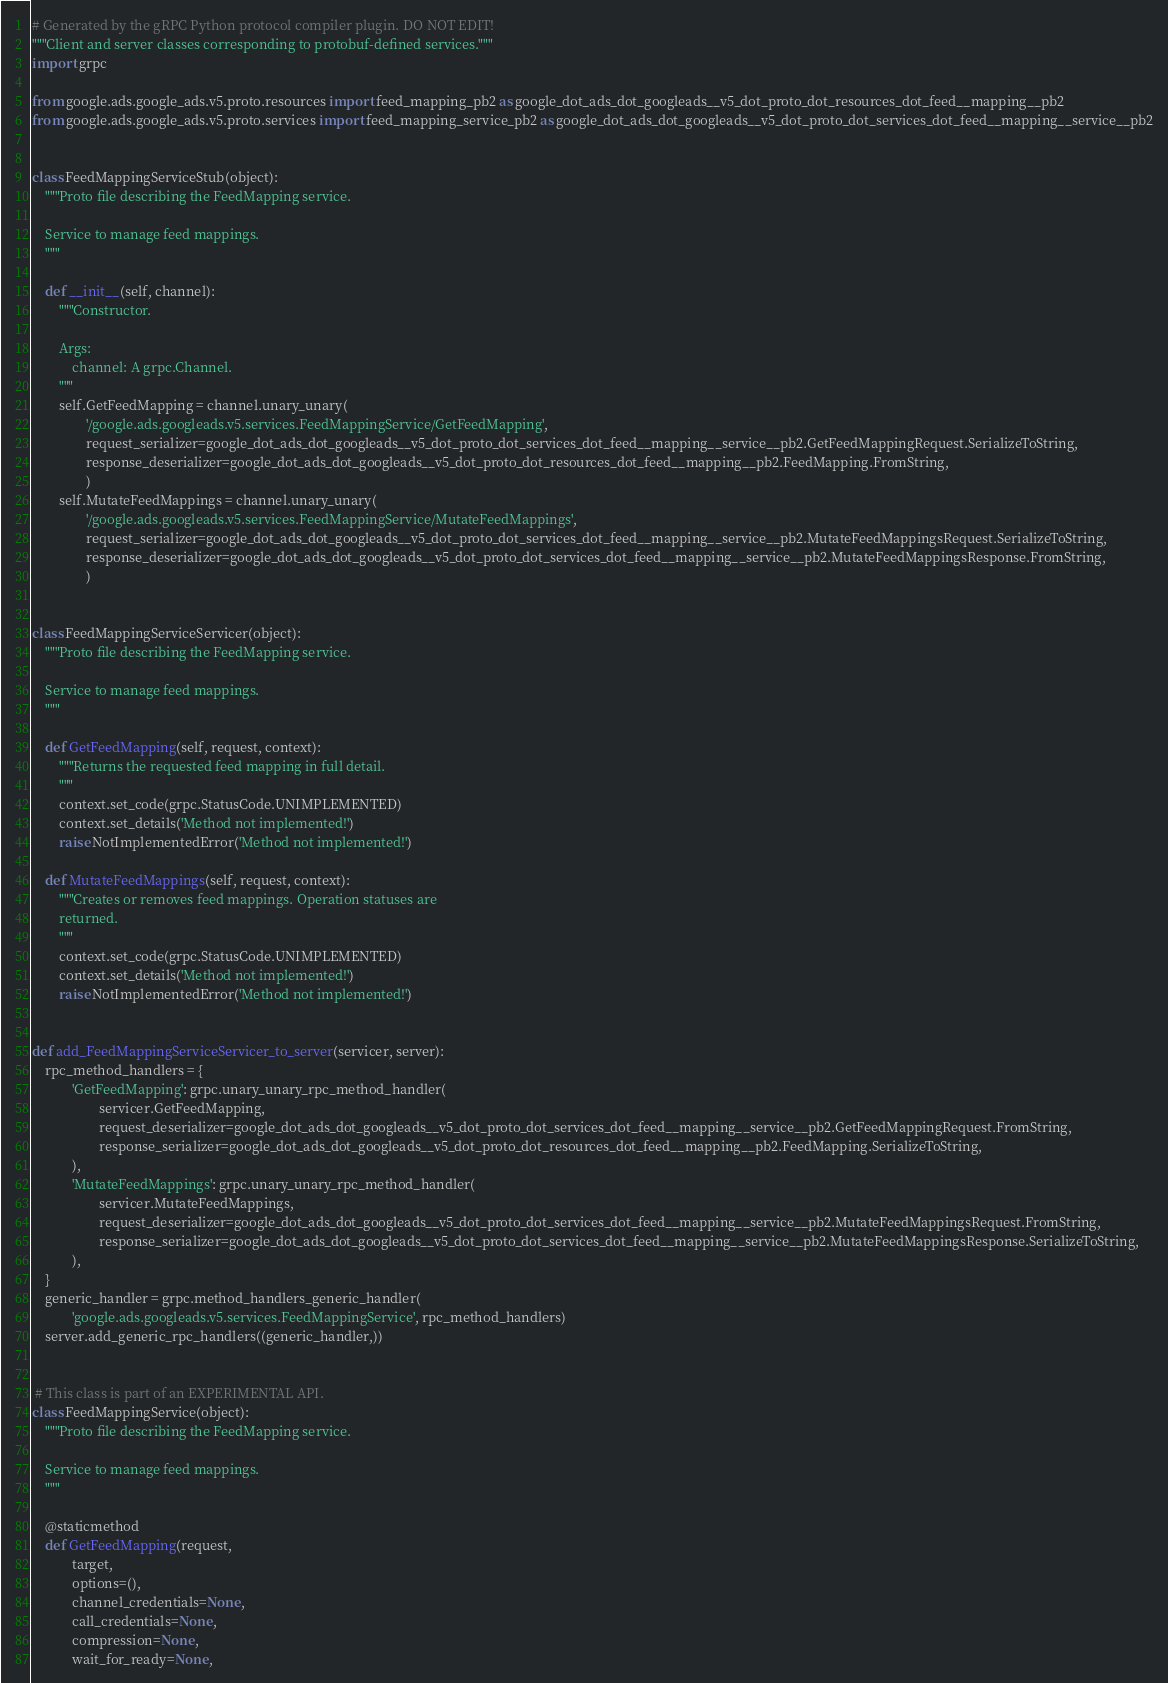Convert code to text. <code><loc_0><loc_0><loc_500><loc_500><_Python_># Generated by the gRPC Python protocol compiler plugin. DO NOT EDIT!
"""Client and server classes corresponding to protobuf-defined services."""
import grpc

from google.ads.google_ads.v5.proto.resources import feed_mapping_pb2 as google_dot_ads_dot_googleads__v5_dot_proto_dot_resources_dot_feed__mapping__pb2
from google.ads.google_ads.v5.proto.services import feed_mapping_service_pb2 as google_dot_ads_dot_googleads__v5_dot_proto_dot_services_dot_feed__mapping__service__pb2


class FeedMappingServiceStub(object):
    """Proto file describing the FeedMapping service.

    Service to manage feed mappings.
    """

    def __init__(self, channel):
        """Constructor.

        Args:
            channel: A grpc.Channel.
        """
        self.GetFeedMapping = channel.unary_unary(
                '/google.ads.googleads.v5.services.FeedMappingService/GetFeedMapping',
                request_serializer=google_dot_ads_dot_googleads__v5_dot_proto_dot_services_dot_feed__mapping__service__pb2.GetFeedMappingRequest.SerializeToString,
                response_deserializer=google_dot_ads_dot_googleads__v5_dot_proto_dot_resources_dot_feed__mapping__pb2.FeedMapping.FromString,
                )
        self.MutateFeedMappings = channel.unary_unary(
                '/google.ads.googleads.v5.services.FeedMappingService/MutateFeedMappings',
                request_serializer=google_dot_ads_dot_googleads__v5_dot_proto_dot_services_dot_feed__mapping__service__pb2.MutateFeedMappingsRequest.SerializeToString,
                response_deserializer=google_dot_ads_dot_googleads__v5_dot_proto_dot_services_dot_feed__mapping__service__pb2.MutateFeedMappingsResponse.FromString,
                )


class FeedMappingServiceServicer(object):
    """Proto file describing the FeedMapping service.

    Service to manage feed mappings.
    """

    def GetFeedMapping(self, request, context):
        """Returns the requested feed mapping in full detail.
        """
        context.set_code(grpc.StatusCode.UNIMPLEMENTED)
        context.set_details('Method not implemented!')
        raise NotImplementedError('Method not implemented!')

    def MutateFeedMappings(self, request, context):
        """Creates or removes feed mappings. Operation statuses are
        returned.
        """
        context.set_code(grpc.StatusCode.UNIMPLEMENTED)
        context.set_details('Method not implemented!')
        raise NotImplementedError('Method not implemented!')


def add_FeedMappingServiceServicer_to_server(servicer, server):
    rpc_method_handlers = {
            'GetFeedMapping': grpc.unary_unary_rpc_method_handler(
                    servicer.GetFeedMapping,
                    request_deserializer=google_dot_ads_dot_googleads__v5_dot_proto_dot_services_dot_feed__mapping__service__pb2.GetFeedMappingRequest.FromString,
                    response_serializer=google_dot_ads_dot_googleads__v5_dot_proto_dot_resources_dot_feed__mapping__pb2.FeedMapping.SerializeToString,
            ),
            'MutateFeedMappings': grpc.unary_unary_rpc_method_handler(
                    servicer.MutateFeedMappings,
                    request_deserializer=google_dot_ads_dot_googleads__v5_dot_proto_dot_services_dot_feed__mapping__service__pb2.MutateFeedMappingsRequest.FromString,
                    response_serializer=google_dot_ads_dot_googleads__v5_dot_proto_dot_services_dot_feed__mapping__service__pb2.MutateFeedMappingsResponse.SerializeToString,
            ),
    }
    generic_handler = grpc.method_handlers_generic_handler(
            'google.ads.googleads.v5.services.FeedMappingService', rpc_method_handlers)
    server.add_generic_rpc_handlers((generic_handler,))


 # This class is part of an EXPERIMENTAL API.
class FeedMappingService(object):
    """Proto file describing the FeedMapping service.

    Service to manage feed mappings.
    """

    @staticmethod
    def GetFeedMapping(request,
            target,
            options=(),
            channel_credentials=None,
            call_credentials=None,
            compression=None,
            wait_for_ready=None,</code> 